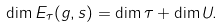<formula> <loc_0><loc_0><loc_500><loc_500>\dim E _ { \tau } ( g , s ) = \dim \tau + \dim U .</formula> 